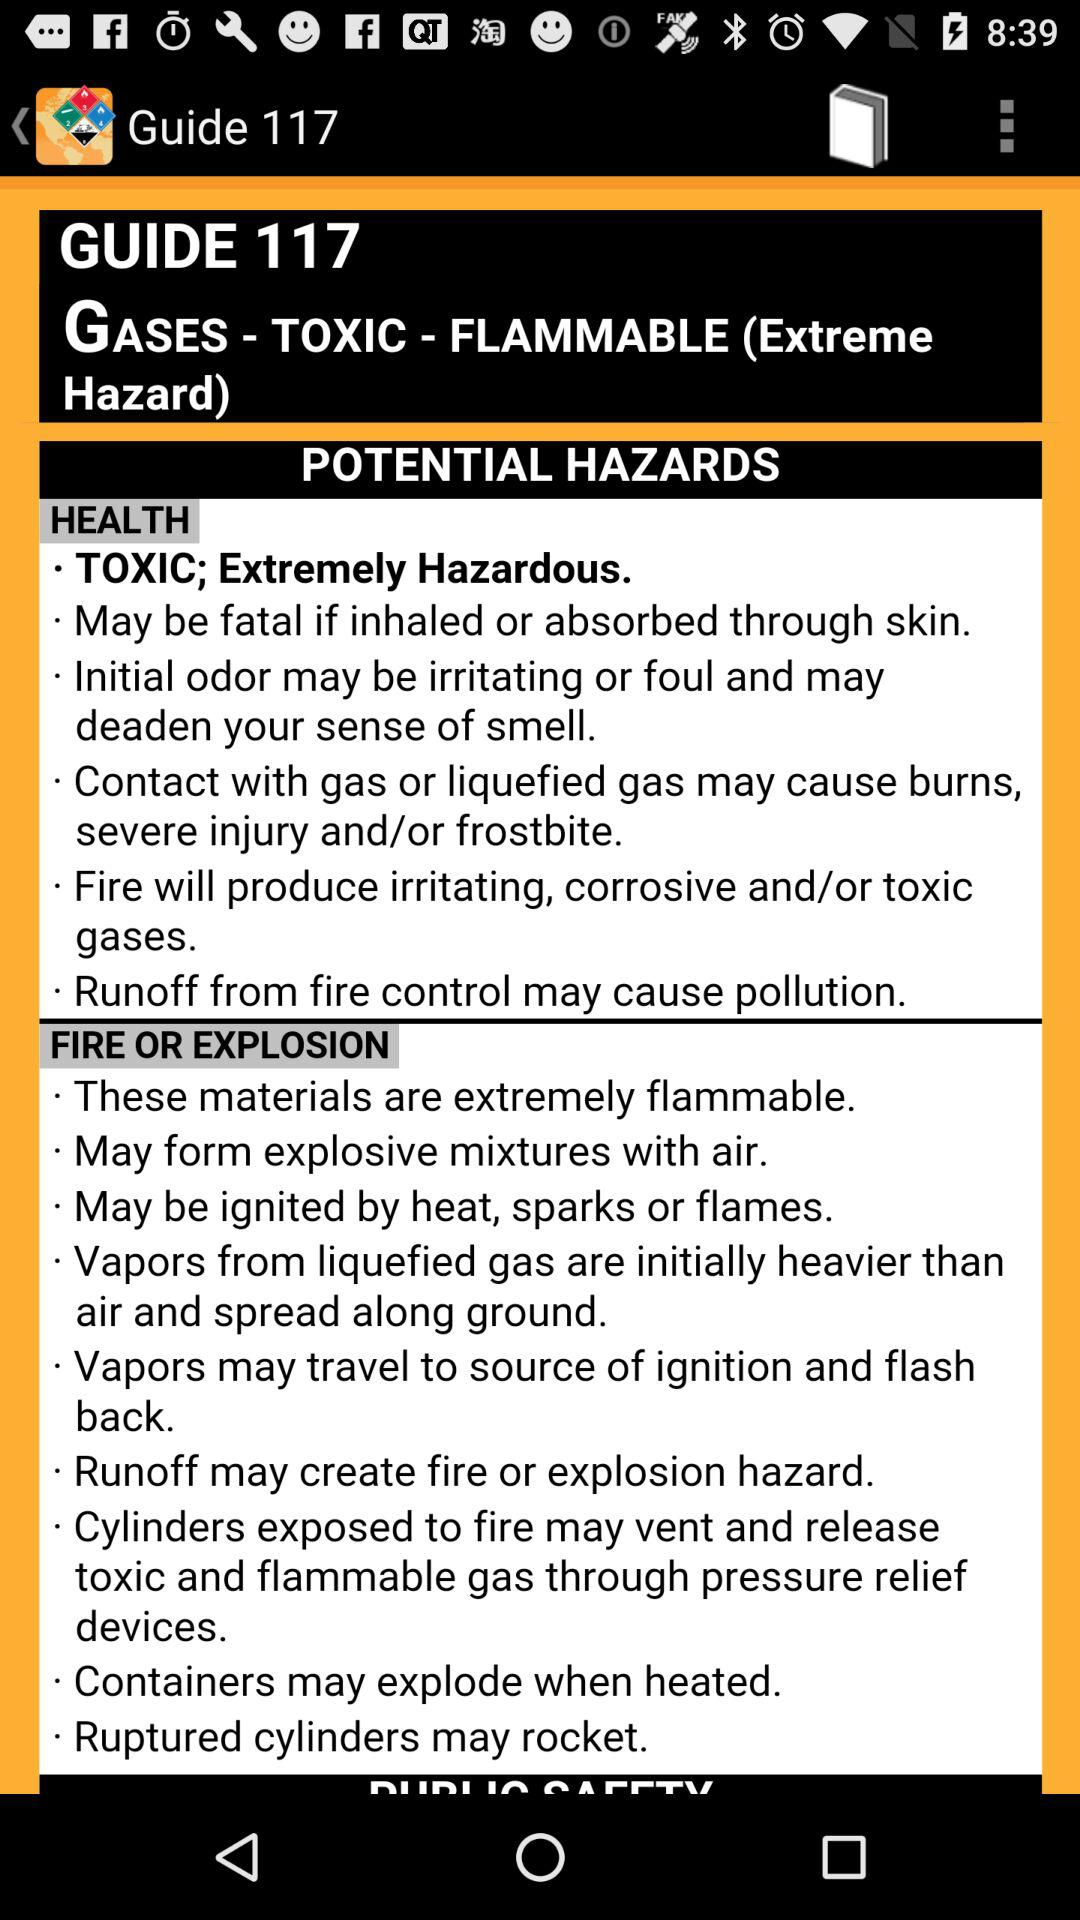How many guides are there in total?
When the provided information is insufficient, respond with <no answer>. <no answer> 